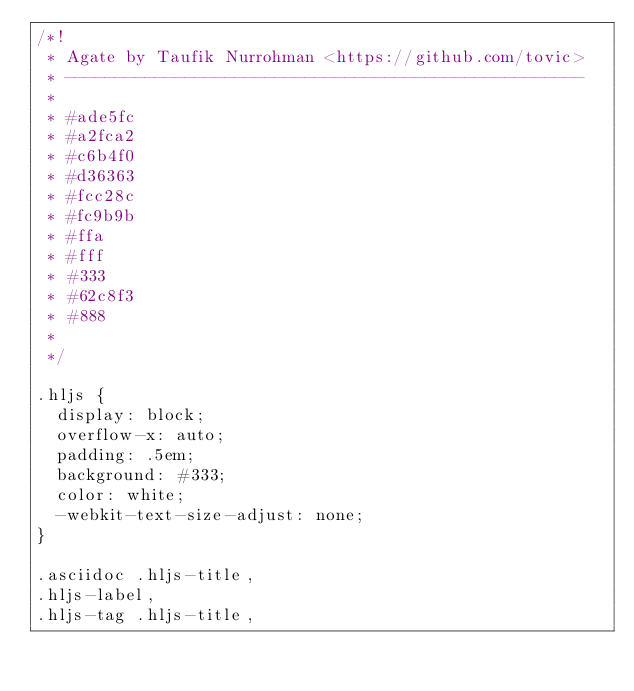<code> <loc_0><loc_0><loc_500><loc_500><_CSS_>/*!
 * Agate by Taufik Nurrohman <https://github.com/tovic>
 * ----------------------------------------------------
 *
 * #ade5fc
 * #a2fca2
 * #c6b4f0
 * #d36363
 * #fcc28c
 * #fc9b9b
 * #ffa
 * #fff
 * #333
 * #62c8f3
 * #888
 *
 */

.hljs {
  display: block;
  overflow-x: auto;
  padding: .5em;
  background: #333;
  color: white;
  -webkit-text-size-adjust: none;
}

.asciidoc .hljs-title,
.hljs-label,
.hljs-tag .hljs-title,</code> 